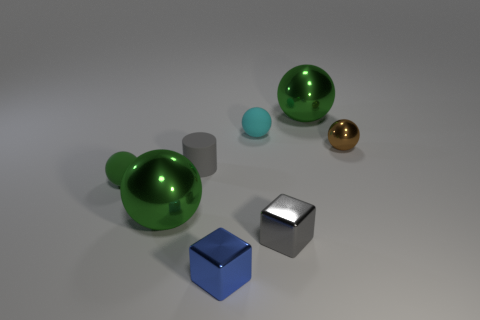What number of things are either green balls that are in front of the green rubber ball or tiny cylinders?
Keep it short and to the point. 2. How many other things are the same color as the cylinder?
Your response must be concise. 1. Are there an equal number of shiny objects that are in front of the small brown metal ball and small cyan objects?
Make the answer very short. No. There is a green shiny ball that is on the left side of the small matte ball behind the tiny green object; what number of large objects are behind it?
Give a very brief answer. 1. There is a gray metal thing; is it the same size as the metal sphere that is behind the small brown ball?
Give a very brief answer. No. What number of brown shiny things are there?
Make the answer very short. 1. There is a rubber ball that is in front of the gray rubber thing; does it have the same size as the rubber sphere that is behind the cylinder?
Provide a succinct answer. Yes. What is the color of the other shiny thing that is the same shape as the blue metallic thing?
Keep it short and to the point. Gray. Is the cyan matte thing the same shape as the brown thing?
Your response must be concise. Yes. There is a gray object that is the same shape as the small blue metal object; what size is it?
Keep it short and to the point. Small. 